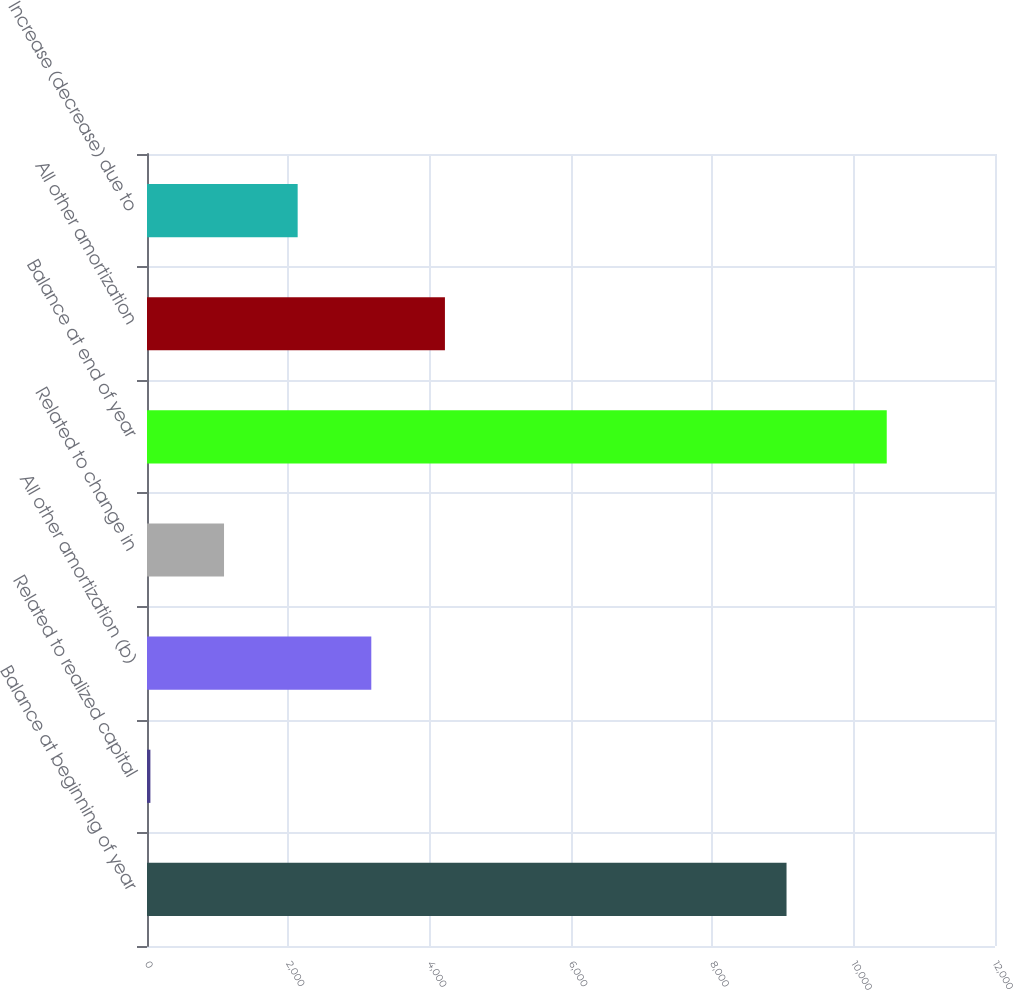<chart> <loc_0><loc_0><loc_500><loc_500><bar_chart><fcel>Balance at beginning of year<fcel>Related to realized capital<fcel>All other amortization (b)<fcel>Related to change in<fcel>Balance at end of year<fcel>All other amortization<fcel>Increase (decrease) due to<nl><fcel>9050<fcel>48<fcel>3174<fcel>1090<fcel>10468<fcel>4216<fcel>2132<nl></chart> 